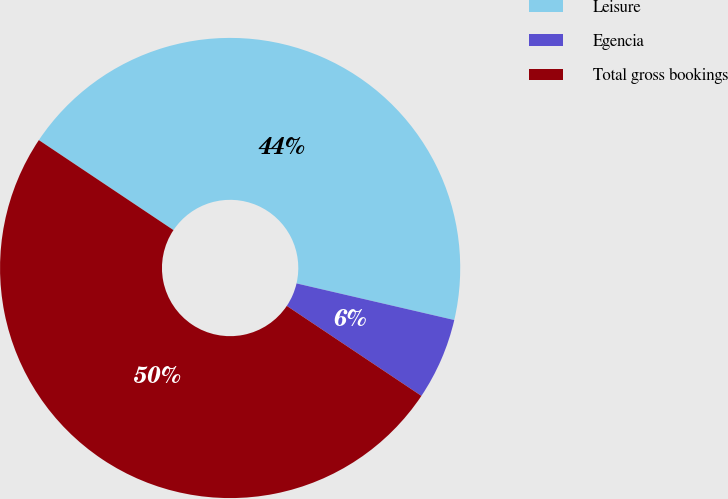Convert chart to OTSL. <chart><loc_0><loc_0><loc_500><loc_500><pie_chart><fcel>Leisure<fcel>Egencia<fcel>Total gross bookings<nl><fcel>44.25%<fcel>5.75%<fcel>50.0%<nl></chart> 